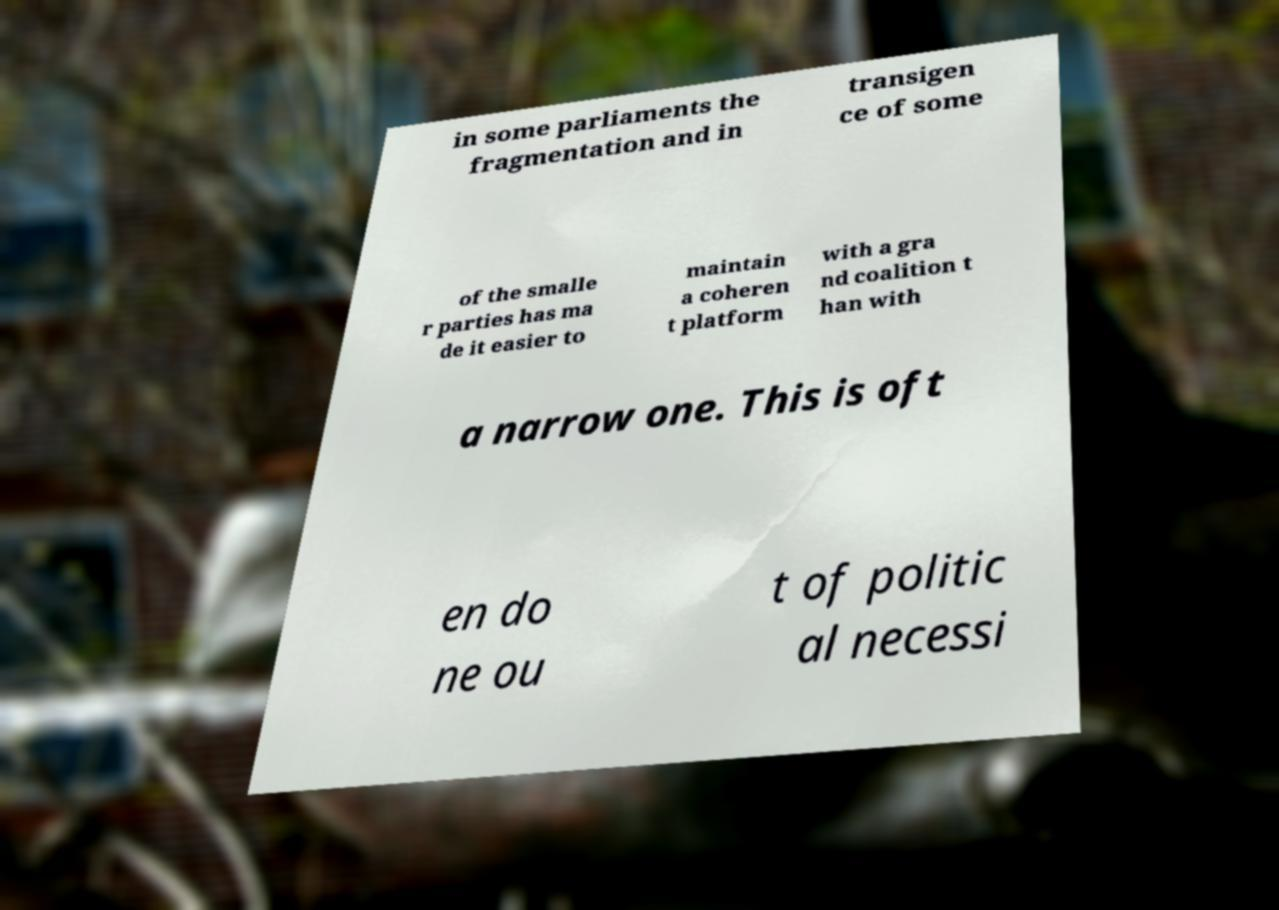For documentation purposes, I need the text within this image transcribed. Could you provide that? in some parliaments the fragmentation and in transigen ce of some of the smalle r parties has ma de it easier to maintain a coheren t platform with a gra nd coalition t han with a narrow one. This is oft en do ne ou t of politic al necessi 